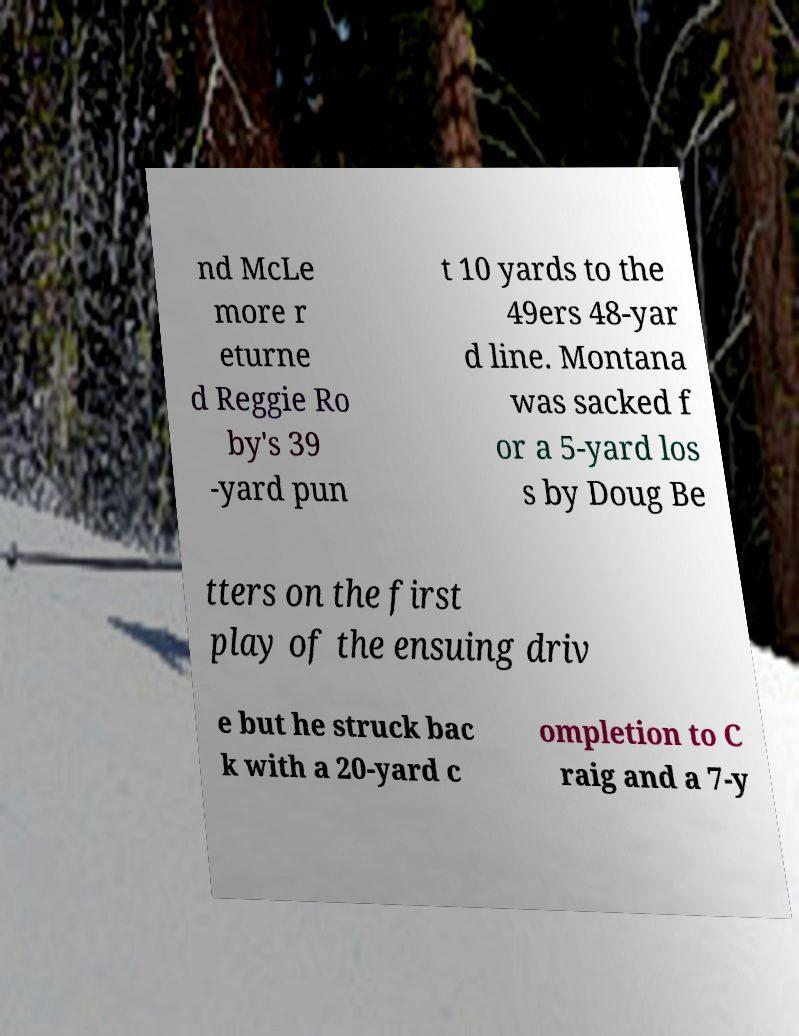There's text embedded in this image that I need extracted. Can you transcribe it verbatim? nd McLe more r eturne d Reggie Ro by's 39 -yard pun t 10 yards to the 49ers 48-yar d line. Montana was sacked f or a 5-yard los s by Doug Be tters on the first play of the ensuing driv e but he struck bac k with a 20-yard c ompletion to C raig and a 7-y 